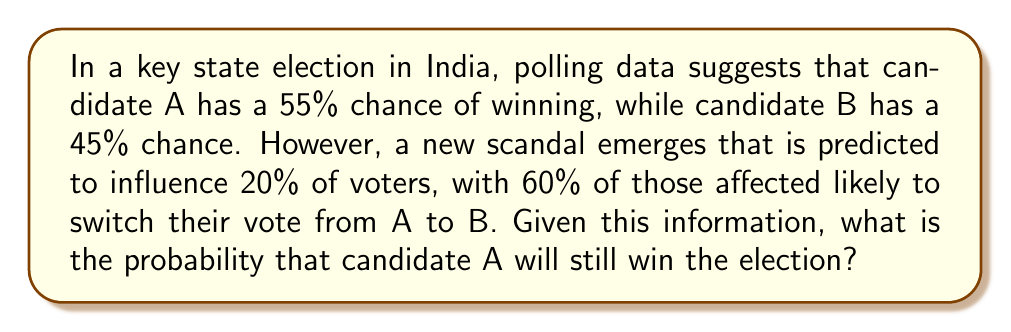Could you help me with this problem? Let's approach this step-by-step:

1) Initially, the probabilities are:
   $P(A) = 0.55$
   $P(B) = 0.45$

2) The scandal affects 20% of voters:
   $0.20 \times 100\% = 20\%$

3) Of those affected, 60% switch from A to B:
   $0.60 \times 20\% = 12\%$

4) This 12% needs to be subtracted from A's probability and added to B's:
   New $P(A) = 0.55 - 0.12 = 0.43$
   New $P(B) = 0.45 + 0.12 = 0.57$

5) To calculate the final probability, we normalize these values:
   $$P(A_{final}) = \frac{0.43}{0.43 + 0.57} = \frac{0.43}{1} = 0.43$$

Therefore, the probability that candidate A will still win the election is 0.43 or 43%.
Answer: 0.43 